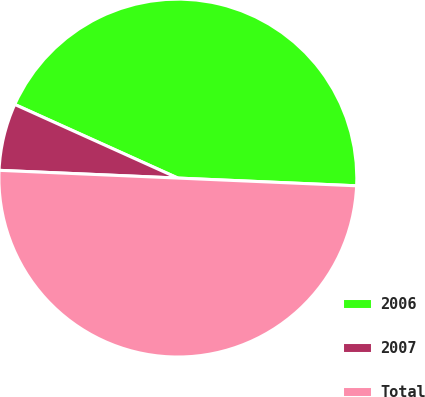Convert chart. <chart><loc_0><loc_0><loc_500><loc_500><pie_chart><fcel>2006<fcel>2007<fcel>Total<nl><fcel>43.94%<fcel>6.06%<fcel>50.0%<nl></chart> 